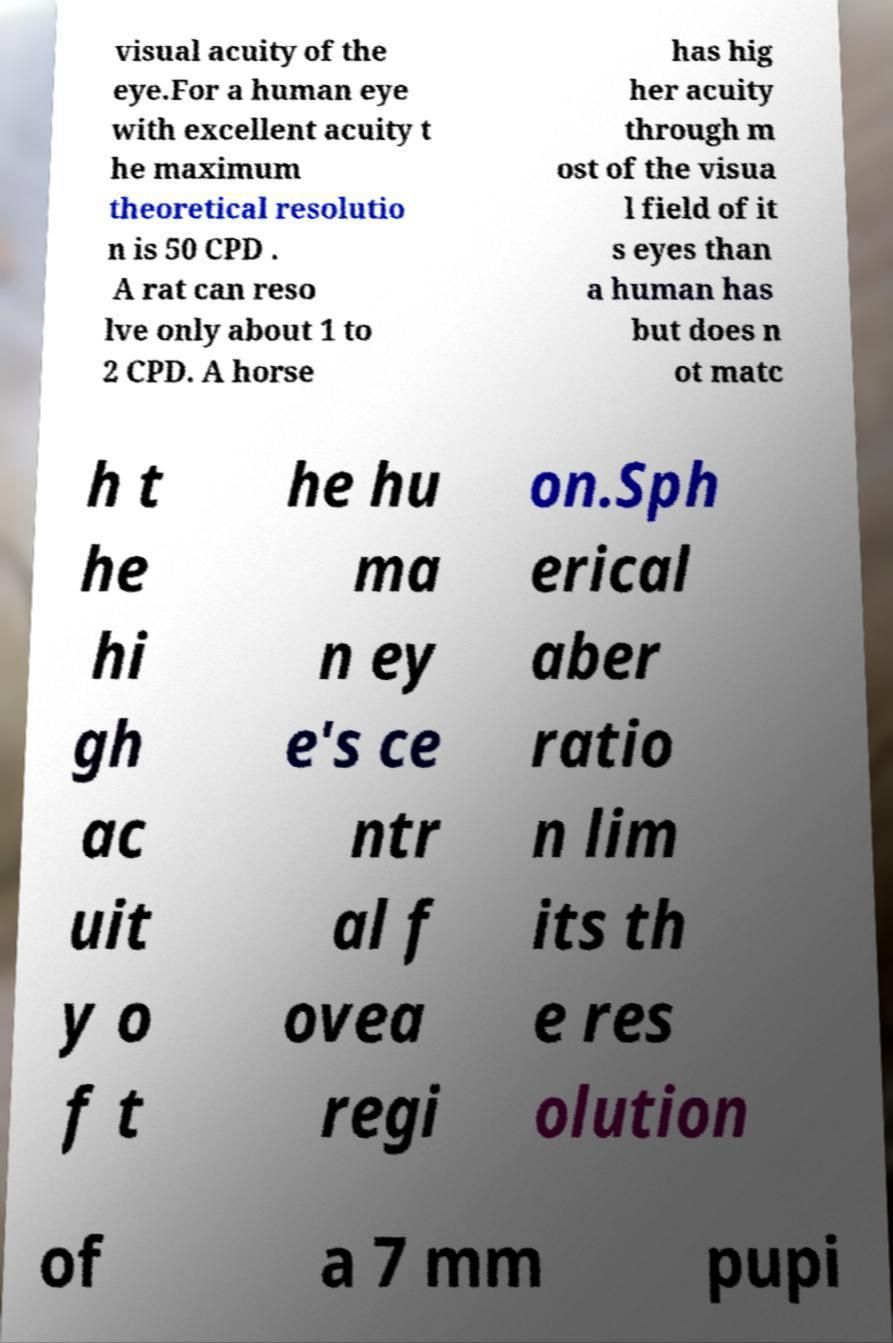I need the written content from this picture converted into text. Can you do that? visual acuity of the eye.For a human eye with excellent acuity t he maximum theoretical resolutio n is 50 CPD . A rat can reso lve only about 1 to 2 CPD. A horse has hig her acuity through m ost of the visua l field of it s eyes than a human has but does n ot matc h t he hi gh ac uit y o f t he hu ma n ey e's ce ntr al f ovea regi on.Sph erical aber ratio n lim its th e res olution of a 7 mm pupi 